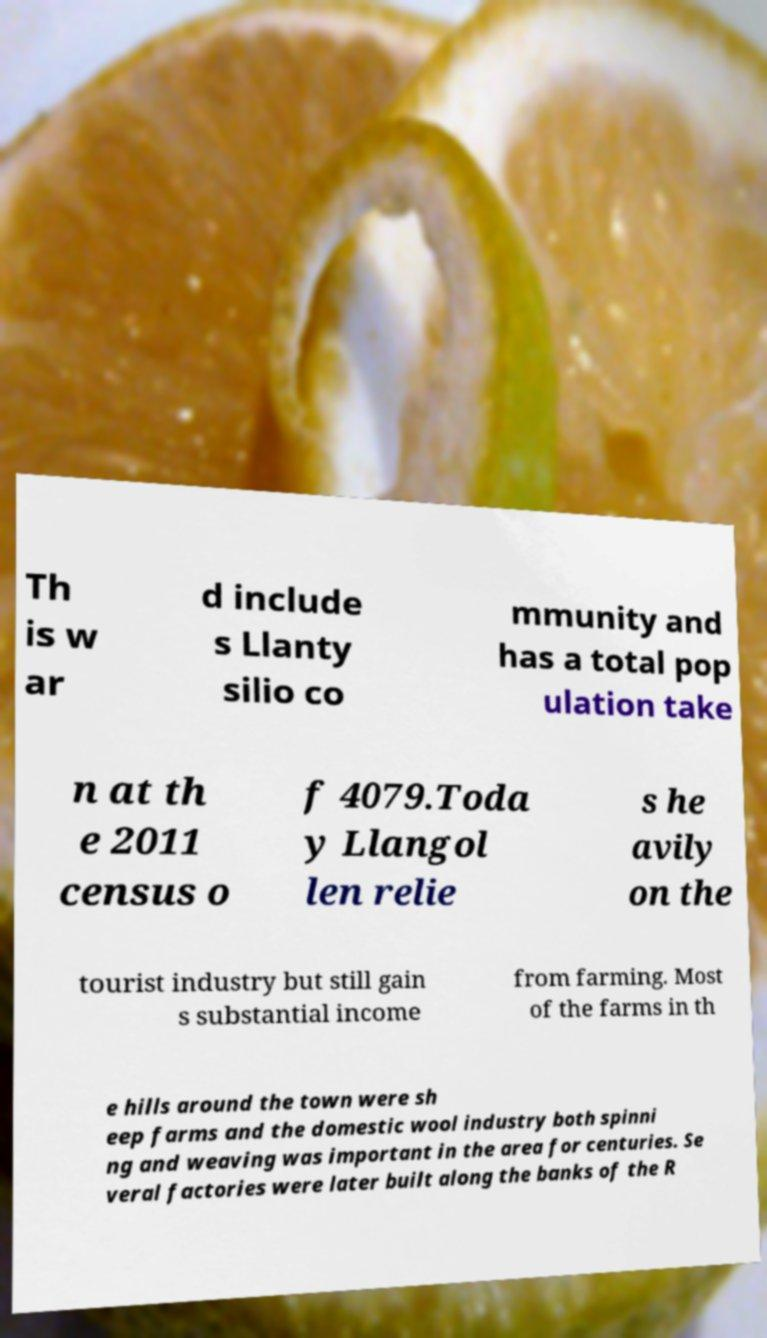Could you extract and type out the text from this image? Th is w ar d include s Llanty silio co mmunity and has a total pop ulation take n at th e 2011 census o f 4079.Toda y Llangol len relie s he avily on the tourist industry but still gain s substantial income from farming. Most of the farms in th e hills around the town were sh eep farms and the domestic wool industry both spinni ng and weaving was important in the area for centuries. Se veral factories were later built along the banks of the R 